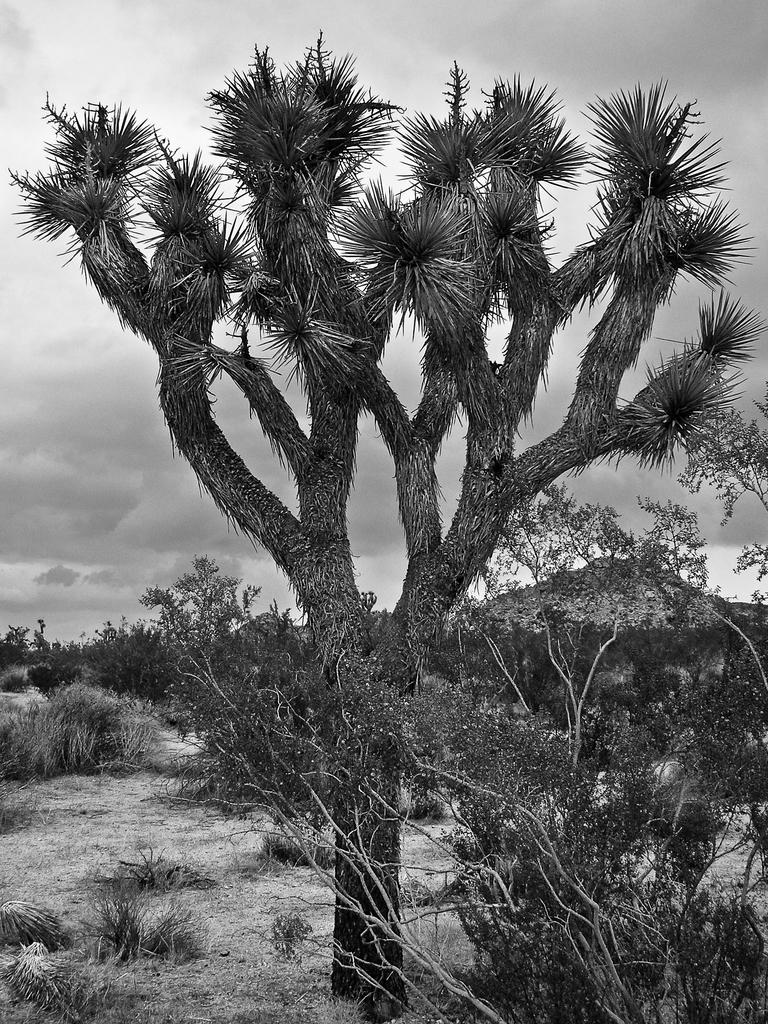What type of vegetation can be seen in the image? There are trees in the image. What part of the natural environment is visible in the image? The sky is visible in the background of the image. What is the color scheme of the image? The image is in black and white. What type of zinc is present in the image? There is no zinc present in the image. How does the watch in the image display the time? There is no watch present in the image. 